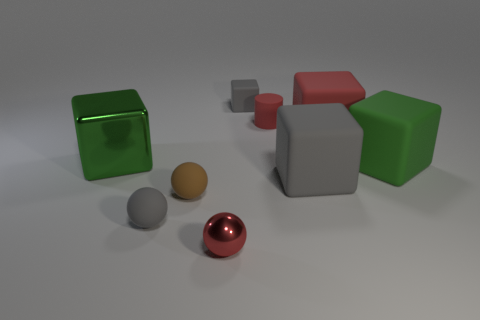Subtract all cyan cubes. Subtract all red cylinders. How many cubes are left? 5 Subtract all cylinders. How many objects are left? 8 Add 1 tiny matte things. How many tiny matte things exist? 5 Subtract 0 brown cylinders. How many objects are left? 9 Subtract all big green metallic objects. Subtract all small metal spheres. How many objects are left? 7 Add 5 big objects. How many big objects are left? 9 